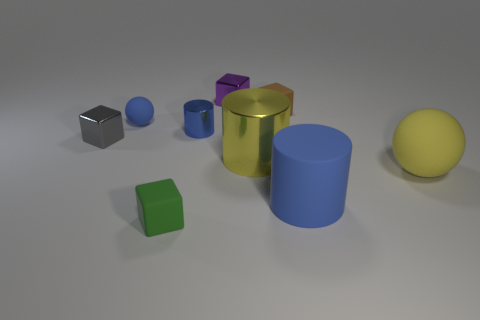Is there another small green object that has the same material as the tiny green thing? After examining the image, it appears that there is only one small green object present. This object has a unique material characteristic that does not match any other items in the scene. 